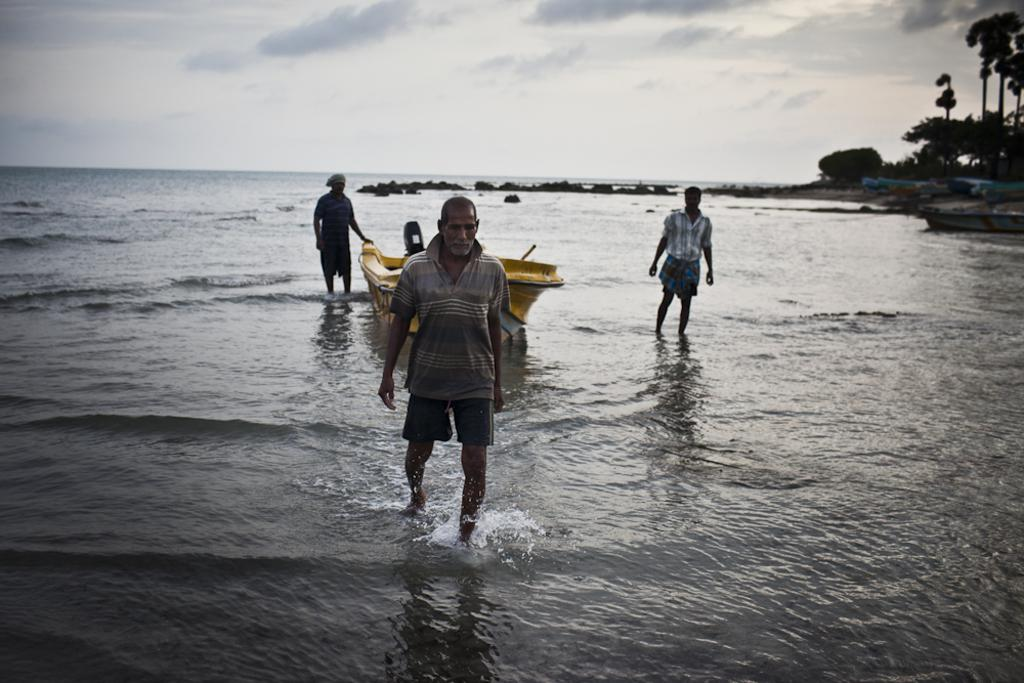What are the three persons in the image doing? The three persons are walking in the water. What can be seen in the background of the image? There is a yellow boat, stones, trees, and a white sky visible in the background. What color is the boat in the background? The boat in the background is yellow in color. Can you tell me how many goats are present in the image? There are no goats present in the image. What type of food is being served for the birthday celebration in the image? There is no birthday celebration or food present in the image. 